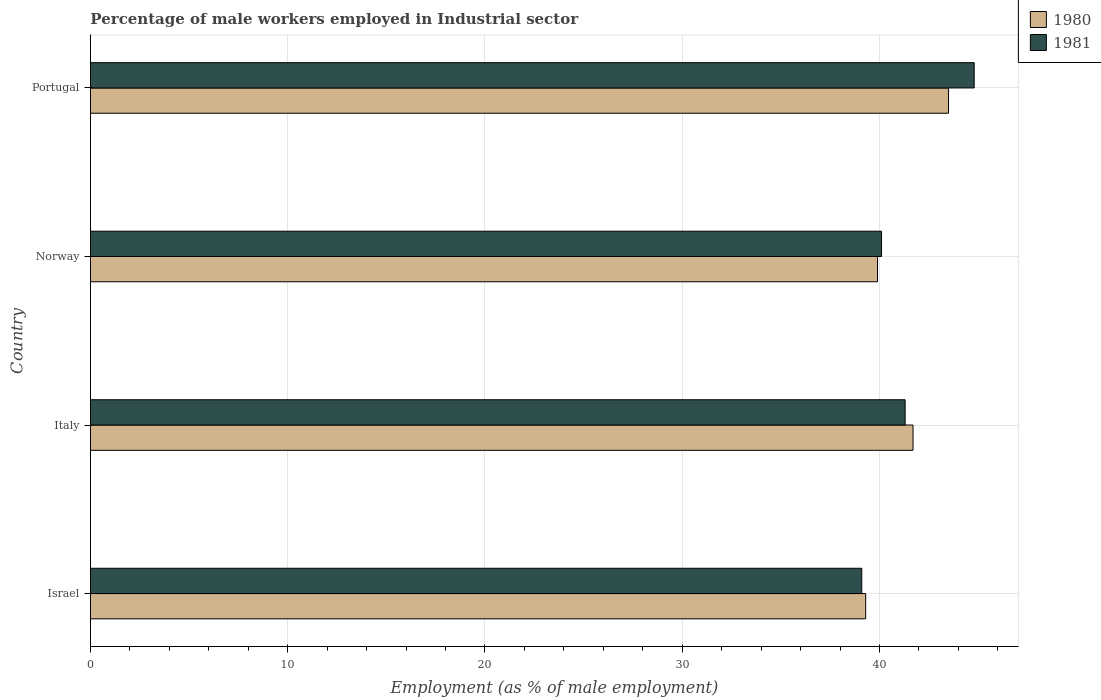How many different coloured bars are there?
Provide a short and direct response. 2. Are the number of bars on each tick of the Y-axis equal?
Your response must be concise. Yes. What is the label of the 3rd group of bars from the top?
Keep it short and to the point. Italy. In how many cases, is the number of bars for a given country not equal to the number of legend labels?
Make the answer very short. 0. What is the percentage of male workers employed in Industrial sector in 1981 in Israel?
Your answer should be very brief. 39.1. Across all countries, what is the maximum percentage of male workers employed in Industrial sector in 1980?
Your response must be concise. 43.5. Across all countries, what is the minimum percentage of male workers employed in Industrial sector in 1981?
Offer a very short reply. 39.1. In which country was the percentage of male workers employed in Industrial sector in 1981 minimum?
Your response must be concise. Israel. What is the total percentage of male workers employed in Industrial sector in 1981 in the graph?
Offer a terse response. 165.3. What is the difference between the percentage of male workers employed in Industrial sector in 1981 in Italy and that in Norway?
Ensure brevity in your answer.  1.2. What is the difference between the percentage of male workers employed in Industrial sector in 1980 in Portugal and the percentage of male workers employed in Industrial sector in 1981 in Israel?
Ensure brevity in your answer.  4.4. What is the average percentage of male workers employed in Industrial sector in 1980 per country?
Provide a succinct answer. 41.1. What is the difference between the percentage of male workers employed in Industrial sector in 1981 and percentage of male workers employed in Industrial sector in 1980 in Italy?
Offer a very short reply. -0.4. What is the ratio of the percentage of male workers employed in Industrial sector in 1981 in Norway to that in Portugal?
Offer a very short reply. 0.9. Is the percentage of male workers employed in Industrial sector in 1980 in Italy less than that in Portugal?
Provide a succinct answer. Yes. Is the difference between the percentage of male workers employed in Industrial sector in 1981 in Israel and Portugal greater than the difference between the percentage of male workers employed in Industrial sector in 1980 in Israel and Portugal?
Provide a succinct answer. No. What is the difference between the highest and the lowest percentage of male workers employed in Industrial sector in 1981?
Give a very brief answer. 5.7. In how many countries, is the percentage of male workers employed in Industrial sector in 1981 greater than the average percentage of male workers employed in Industrial sector in 1981 taken over all countries?
Make the answer very short. 1. Is the sum of the percentage of male workers employed in Industrial sector in 1980 in Israel and Portugal greater than the maximum percentage of male workers employed in Industrial sector in 1981 across all countries?
Ensure brevity in your answer.  Yes. What does the 2nd bar from the top in Norway represents?
Make the answer very short. 1980. What does the 1st bar from the bottom in Italy represents?
Offer a very short reply. 1980. How many bars are there?
Provide a short and direct response. 8. Does the graph contain any zero values?
Your response must be concise. No. How are the legend labels stacked?
Offer a terse response. Vertical. What is the title of the graph?
Your response must be concise. Percentage of male workers employed in Industrial sector. Does "1980" appear as one of the legend labels in the graph?
Your answer should be compact. Yes. What is the label or title of the X-axis?
Provide a short and direct response. Employment (as % of male employment). What is the Employment (as % of male employment) of 1980 in Israel?
Provide a short and direct response. 39.3. What is the Employment (as % of male employment) of 1981 in Israel?
Provide a short and direct response. 39.1. What is the Employment (as % of male employment) of 1980 in Italy?
Your response must be concise. 41.7. What is the Employment (as % of male employment) in 1981 in Italy?
Your response must be concise. 41.3. What is the Employment (as % of male employment) of 1980 in Norway?
Ensure brevity in your answer.  39.9. What is the Employment (as % of male employment) of 1981 in Norway?
Your answer should be very brief. 40.1. What is the Employment (as % of male employment) of 1980 in Portugal?
Offer a terse response. 43.5. What is the Employment (as % of male employment) of 1981 in Portugal?
Offer a terse response. 44.8. Across all countries, what is the maximum Employment (as % of male employment) of 1980?
Offer a terse response. 43.5. Across all countries, what is the maximum Employment (as % of male employment) of 1981?
Make the answer very short. 44.8. Across all countries, what is the minimum Employment (as % of male employment) of 1980?
Ensure brevity in your answer.  39.3. Across all countries, what is the minimum Employment (as % of male employment) in 1981?
Ensure brevity in your answer.  39.1. What is the total Employment (as % of male employment) in 1980 in the graph?
Ensure brevity in your answer.  164.4. What is the total Employment (as % of male employment) in 1981 in the graph?
Make the answer very short. 165.3. What is the difference between the Employment (as % of male employment) of 1980 in Israel and that in Italy?
Ensure brevity in your answer.  -2.4. What is the difference between the Employment (as % of male employment) of 1980 in Israel and that in Norway?
Give a very brief answer. -0.6. What is the difference between the Employment (as % of male employment) in 1980 in Israel and that in Portugal?
Give a very brief answer. -4.2. What is the difference between the Employment (as % of male employment) of 1981 in Italy and that in Norway?
Keep it short and to the point. 1.2. What is the difference between the Employment (as % of male employment) of 1980 in Israel and the Employment (as % of male employment) of 1981 in Italy?
Provide a short and direct response. -2. What is the difference between the Employment (as % of male employment) in 1980 in Israel and the Employment (as % of male employment) in 1981 in Portugal?
Your answer should be very brief. -5.5. What is the difference between the Employment (as % of male employment) of 1980 in Italy and the Employment (as % of male employment) of 1981 in Norway?
Offer a terse response. 1.6. What is the difference between the Employment (as % of male employment) in 1980 in Italy and the Employment (as % of male employment) in 1981 in Portugal?
Give a very brief answer. -3.1. What is the average Employment (as % of male employment) of 1980 per country?
Your response must be concise. 41.1. What is the average Employment (as % of male employment) in 1981 per country?
Keep it short and to the point. 41.33. What is the difference between the Employment (as % of male employment) of 1980 and Employment (as % of male employment) of 1981 in Israel?
Provide a short and direct response. 0.2. What is the difference between the Employment (as % of male employment) in 1980 and Employment (as % of male employment) in 1981 in Italy?
Ensure brevity in your answer.  0.4. What is the difference between the Employment (as % of male employment) of 1980 and Employment (as % of male employment) of 1981 in Portugal?
Provide a succinct answer. -1.3. What is the ratio of the Employment (as % of male employment) in 1980 in Israel to that in Italy?
Offer a very short reply. 0.94. What is the ratio of the Employment (as % of male employment) in 1981 in Israel to that in Italy?
Your response must be concise. 0.95. What is the ratio of the Employment (as % of male employment) of 1980 in Israel to that in Norway?
Give a very brief answer. 0.98. What is the ratio of the Employment (as % of male employment) of 1981 in Israel to that in Norway?
Your answer should be compact. 0.98. What is the ratio of the Employment (as % of male employment) in 1980 in Israel to that in Portugal?
Your answer should be very brief. 0.9. What is the ratio of the Employment (as % of male employment) in 1981 in Israel to that in Portugal?
Your response must be concise. 0.87. What is the ratio of the Employment (as % of male employment) in 1980 in Italy to that in Norway?
Your response must be concise. 1.05. What is the ratio of the Employment (as % of male employment) of 1981 in Italy to that in Norway?
Provide a succinct answer. 1.03. What is the ratio of the Employment (as % of male employment) in 1980 in Italy to that in Portugal?
Your response must be concise. 0.96. What is the ratio of the Employment (as % of male employment) of 1981 in Italy to that in Portugal?
Your answer should be compact. 0.92. What is the ratio of the Employment (as % of male employment) in 1980 in Norway to that in Portugal?
Your answer should be compact. 0.92. What is the ratio of the Employment (as % of male employment) of 1981 in Norway to that in Portugal?
Ensure brevity in your answer.  0.9. What is the difference between the highest and the second highest Employment (as % of male employment) of 1981?
Give a very brief answer. 3.5. What is the difference between the highest and the lowest Employment (as % of male employment) in 1980?
Offer a very short reply. 4.2. What is the difference between the highest and the lowest Employment (as % of male employment) in 1981?
Provide a short and direct response. 5.7. 